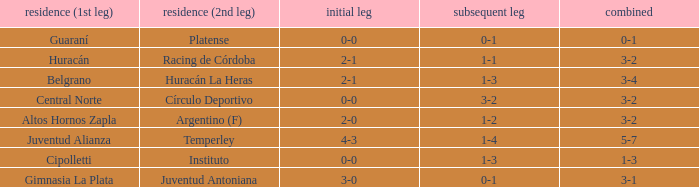Which team played their first leg at home with an aggregate score of 3-4? Belgrano. 